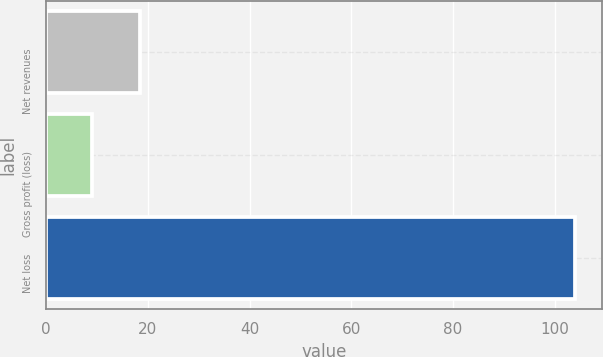<chart> <loc_0><loc_0><loc_500><loc_500><bar_chart><fcel>Net revenues<fcel>Gross profit (loss)<fcel>Net loss<nl><fcel>18.5<fcel>9<fcel>104<nl></chart> 